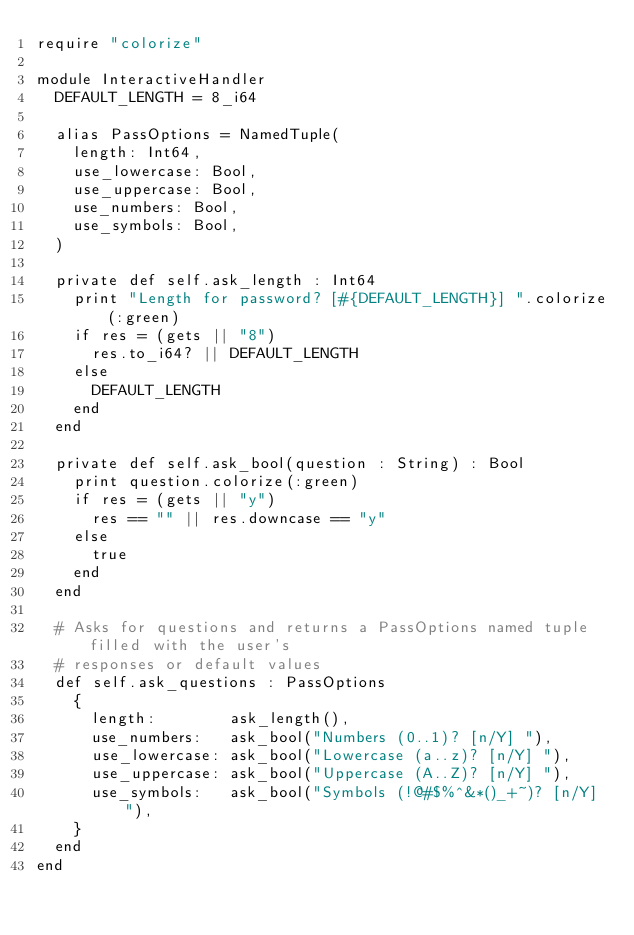<code> <loc_0><loc_0><loc_500><loc_500><_Crystal_>require "colorize"

module InteractiveHandler
  DEFAULT_LENGTH = 8_i64

  alias PassOptions = NamedTuple(
    length: Int64,
    use_lowercase: Bool,
    use_uppercase: Bool,
    use_numbers: Bool,
    use_symbols: Bool,
  )

  private def self.ask_length : Int64
    print "Length for password? [#{DEFAULT_LENGTH}] ".colorize(:green)
    if res = (gets || "8")
      res.to_i64? || DEFAULT_LENGTH
    else
      DEFAULT_LENGTH
    end
  end

  private def self.ask_bool(question : String) : Bool
    print question.colorize(:green)
    if res = (gets || "y")
      res == "" || res.downcase == "y"
    else
      true
    end
  end

  # Asks for questions and returns a PassOptions named tuple filled with the user's
  # responses or default values
  def self.ask_questions : PassOptions
    {
      length:        ask_length(),
      use_numbers:   ask_bool("Numbers (0..1)? [n/Y] "),
      use_lowercase: ask_bool("Lowercase (a..z)? [n/Y] "),
      use_uppercase: ask_bool("Uppercase (A..Z)? [n/Y] "),
      use_symbols:   ask_bool("Symbols (!@#$%^&*()_+~)? [n/Y] "),
    }
  end
end
</code> 